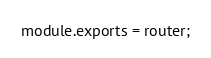Convert code to text. <code><loc_0><loc_0><loc_500><loc_500><_JavaScript_>
module.exports = router;</code> 